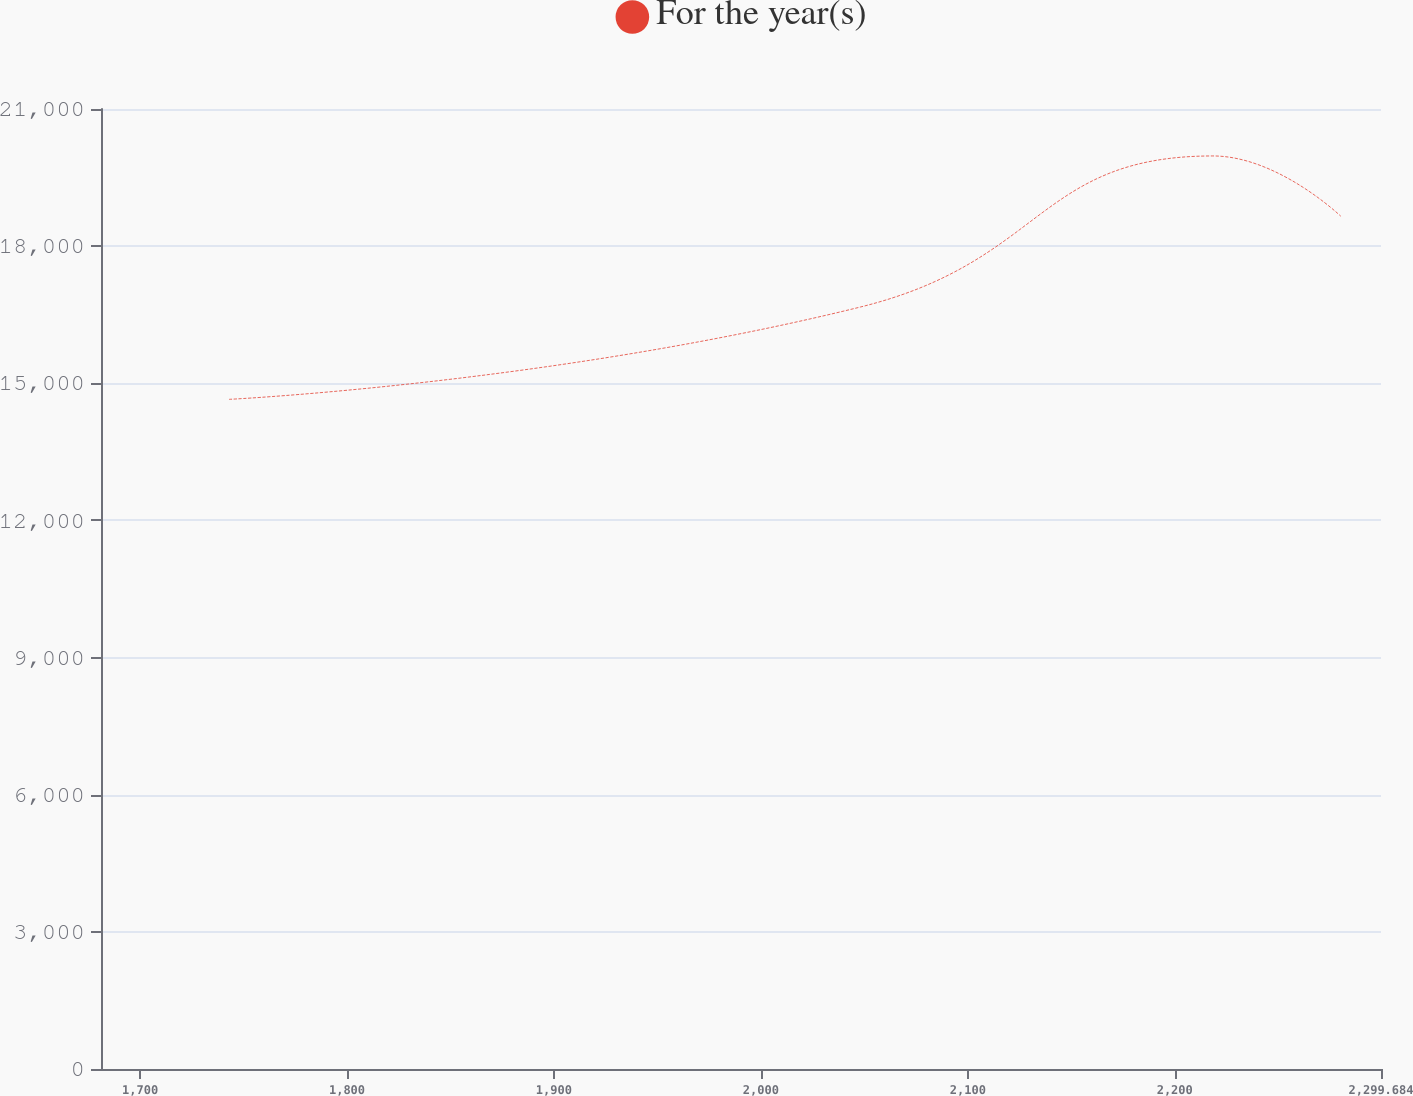<chart> <loc_0><loc_0><loc_500><loc_500><line_chart><ecel><fcel>For the year(s)<nl><fcel>1742.98<fcel>14648.5<nl><fcel>2048.09<fcel>16668.3<nl><fcel>2218.42<fcel>19972.9<nl><fcel>2280.28<fcel>18653.7<nl><fcel>2361.54<fcel>16135.8<nl></chart> 